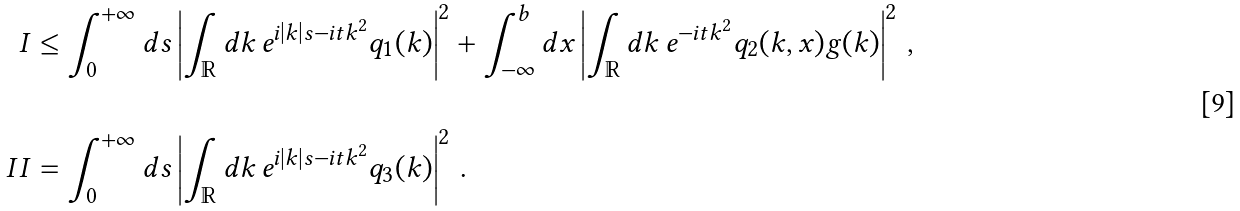<formula> <loc_0><loc_0><loc_500><loc_500>I & \leq \int _ { 0 } ^ { + \infty } d s \left | \int _ { \mathbb { R } } d k \, e ^ { i \left | k \right | s - i t k ^ { 2 } } q _ { 1 } ( k ) \right | ^ { 2 } + \int _ { - \infty } ^ { b } d x \left | \int _ { \mathbb { R } } d k \, e ^ { - i t k ^ { 2 } } q _ { 2 } ( k , x ) g ( k ) \right | ^ { 2 } \, , \\ & \\ I I & = \int _ { 0 } ^ { + \infty } d s \left | \int _ { \mathbb { R } } d k \, e ^ { i \left | k \right | s - i t k ^ { 2 } } q _ { 3 } ( k ) \right | ^ { 2 } \, .</formula> 